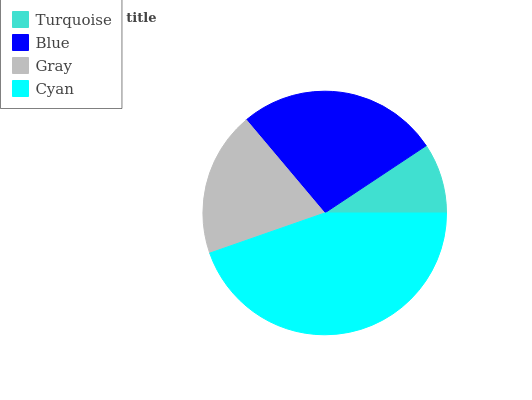Is Turquoise the minimum?
Answer yes or no. Yes. Is Cyan the maximum?
Answer yes or no. Yes. Is Blue the minimum?
Answer yes or no. No. Is Blue the maximum?
Answer yes or no. No. Is Blue greater than Turquoise?
Answer yes or no. Yes. Is Turquoise less than Blue?
Answer yes or no. Yes. Is Turquoise greater than Blue?
Answer yes or no. No. Is Blue less than Turquoise?
Answer yes or no. No. Is Blue the high median?
Answer yes or no. Yes. Is Gray the low median?
Answer yes or no. Yes. Is Turquoise the high median?
Answer yes or no. No. Is Cyan the low median?
Answer yes or no. No. 